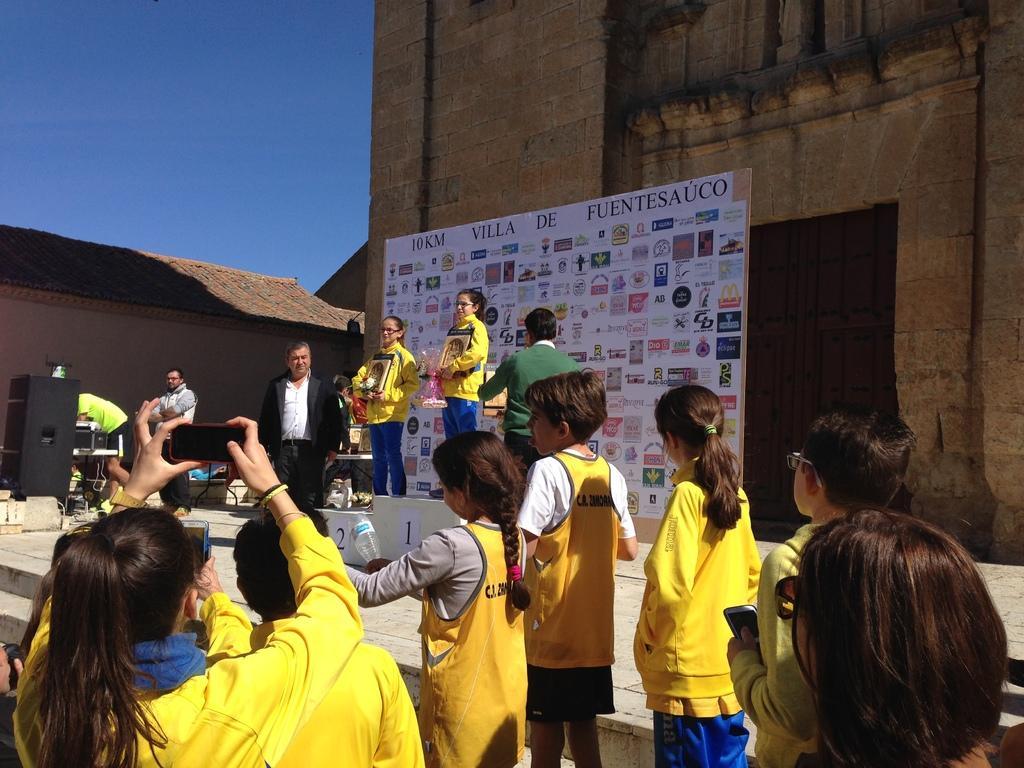Please provide a concise description of this image. In this image I can see few people standing and wearing different color dresses. I can see few people are holding awards. I can see speakers,few objects,building and white banner. The sky is in blue color. 